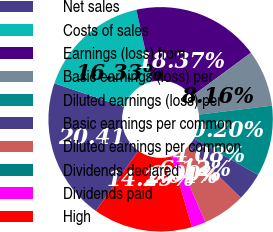Convert chart to OTSL. <chart><loc_0><loc_0><loc_500><loc_500><pie_chart><fcel>Net sales<fcel>Costs of sales<fcel>Earnings (loss) from<fcel>Basic earnings (loss) per<fcel>Diluted earnings (loss) per<fcel>Basic earnings per common<fcel>Diluted earnings per common<fcel>Dividends declared<fcel>Dividends paid<fcel>High<nl><fcel>20.4%<fcel>16.32%<fcel>18.36%<fcel>8.16%<fcel>10.2%<fcel>4.08%<fcel>6.12%<fcel>0.0%<fcel>2.04%<fcel>14.28%<nl></chart> 